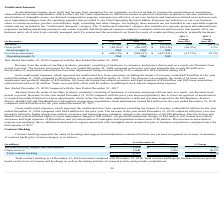According to Allscripts Healthcare Solutions's financial document, What led to increase in revenue for the year ended December 31, 2019 compared to the prior year? due to only $2 million in amortization of acquisition-related deferred revenue adjustments being recorded during 2019, compared to $24.3 million during 2018.. The document states: "31, 2019 compared to the prior year was primarily due to only $2 million in amortization of acquisition-related deferred revenue adjustments being rec..." Also, What led to decrease in Gross unallocated expenses for the year ended December 31, 2019 compared to the prior year? Based on the financial document, the answer is primarily the result of (i) lower asset impairment and goodwill charges of $35 million, (ii) lower net transaction-related severance and legal expenses of $16 million and (iii) lower acquisition related amortization of $1 million.. Also, What led to increase in revenue for the year ended December 31, 2018 compared to the prior year? due to lower recognition of amortization of acquisition-related deferred revenue adjustments, which reflect the fair value adjustments to deferred revenues acquired in the EIS Business, Practice Fusion, Health Grid and NantHealth provider/patient engagement acquisitions.. The document states: "18 compared with the prior year improved primarily due to lower recognition of amortization of acquisition-related deferred revenue adjustments, which..." Also, can you calculate: What is the change in Revenue between 2019 and 2017? Based on the calculation: 13,346-(13,383), the result is 26729 (in thousands). This is based on the information: "Revenue $ 13,346 $ (6,386) $ (13,383) NM (52.3%) Revenue $ 13,346 $ (6,386) $ (13,383) NM (52.3%)..." The key data points involved are: 13,346, 13,383. Additionally, Which year has the highest revenue? According to the financial document, 2019. The relevant text states: "2019 % 2018 %..." Additionally, Which years has negative gross profit value? The document contains multiple relevant values: 2019, 2018, 2017. From the document: "(In thousands) 2019 2018 2017 from 2018 from 2017 2019 % 2018 % 2019 % 2018 %..." 